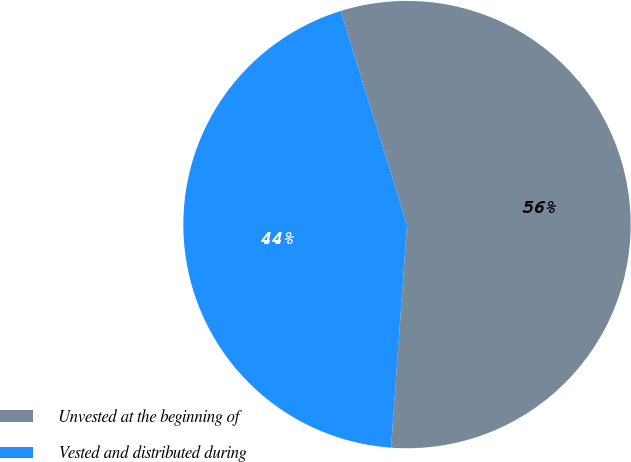Convert chart to OTSL. <chart><loc_0><loc_0><loc_500><loc_500><pie_chart><fcel>Unvested at the beginning of<fcel>Vested and distributed during<nl><fcel>55.93%<fcel>44.07%<nl></chart> 